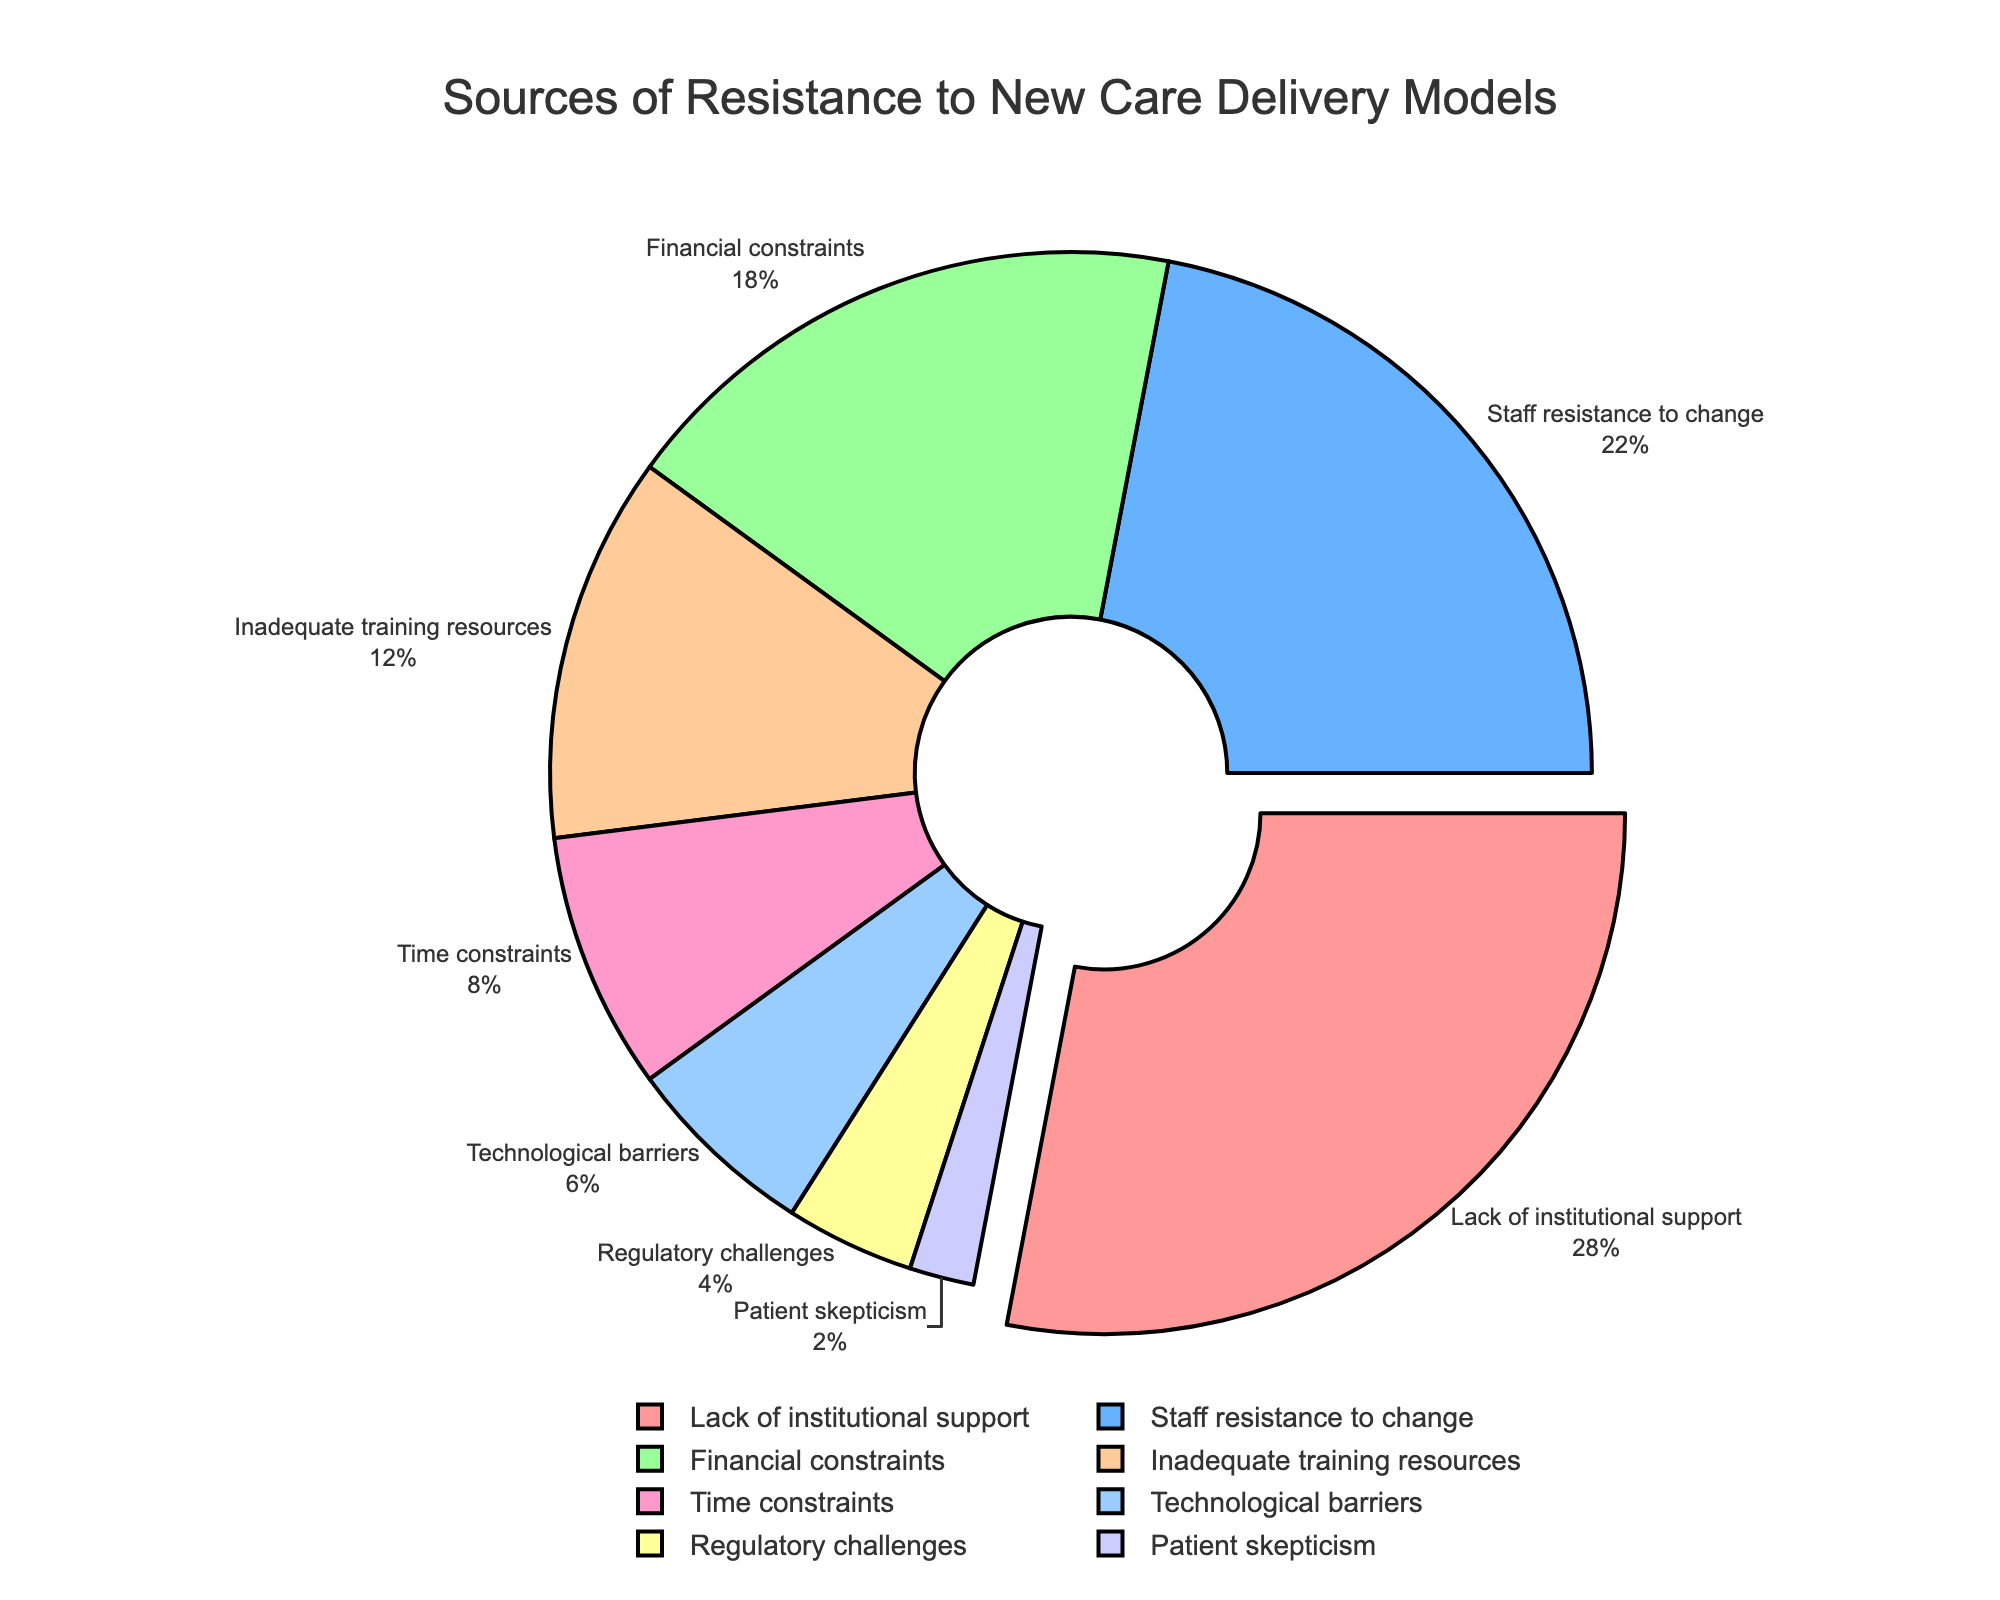Which source has the highest percentage of resistance? The figure shows a pie chart with different sources of resistance and their corresponding percentages. The largest slice, with 28%, represents the source with the highest resistance.
Answer: Lack of institutional support What is the combined percentage of 'Inadequate training resources' and 'Time constraints'? The figure shows that 'Inadequate training resources' has 12% and 'Time constraints' has 8%. Adding these percentages gives 12% + 8% = 20%.
Answer: 20% Which source has the smallest percentage of resistance? The pie chart shows several sources of resistance, and the smallest slice represents 'Patient skepticism' with 2%.
Answer: Patient skepticism Compare the percentage of 'Staff resistance to change' to 'Financial constraints'. Which is higher? The figure shows 'Staff resistance to change' at 22% and 'Financial constraints' at 18%. Therefore, 'Staff resistance to change' is higher.
Answer: Staff resistance to change What is the difference in the percentage between 'Technological barriers' and 'Regulatory challenges'? The figure shows 'Technological barriers' at 6% and 'Regulatory challenges' at 4%. The difference is 6% - 4% = 2%.
Answer: 2% Which source of resistance appears in a blue segment in the pie chart? The task description indicates the colors used in the pie chart and 'Staff resistance to change' appears in the blue segment.
Answer: Staff resistance to change How many sources have a percentage lower than 10%? The figure shows the percentages for each source of resistance. The sources with percentages lower than 10% are 'Time constraints' (8%), 'Technological barriers' (6%), 'Regulatory challenges' (4%), and 'Patient skepticism' (2%), making a total of four sources.
Answer: 4 If you combine the percentages of 'Regulatory challenges' and 'Patient skepticism', is the total still less than 'Technological barriers'? 'Regulatory challenges' is 4% and 'Patient skepticism' is 2%. Adding them gives 4% + 2% = 6%, which is equal to 'Technological barriers'.
Answer: Yes What is the average percentage of all the sources of resistance? To find the average, sum all the percentages: 28% + 22% + 18% + 12% + 8% + 6% + 4% + 2% = 100%. There are 8 sources, so the average is 100% / 8 = 12.5%.
Answer: 12.5% What percentage of resistance is represented by sources other than 'Lack of institutional support'? 'Lack of institutional support' has 28%. Subtracting from the total 100% gives 100% - 28% = 72%.
Answer: 72% 